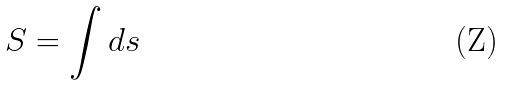<formula> <loc_0><loc_0><loc_500><loc_500>S = \int d s</formula> 